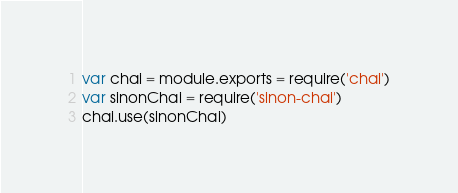Convert code to text. <code><loc_0><loc_0><loc_500><loc_500><_JavaScript_>var chai = module.exports = require('chai')
var sinonChai = require('sinon-chai')
chai.use(sinonChai)
</code> 